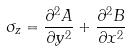Convert formula to latex. <formula><loc_0><loc_0><loc_500><loc_500>\sigma _ { z } = \frac { \partial ^ { 2 } A } { \partial y ^ { 2 } } + \frac { \partial ^ { 2 } B } { \partial x ^ { 2 } }</formula> 